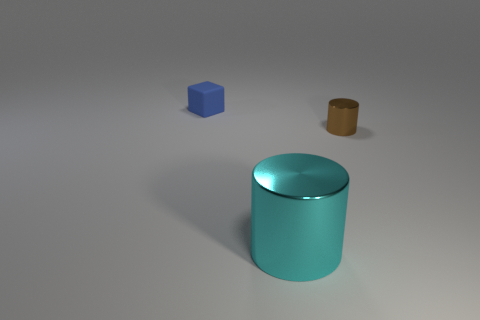Is there any other thing that is the same shape as the blue object?
Provide a succinct answer. No. What is the shape of the small rubber thing?
Give a very brief answer. Cube. What is the small object to the right of the thing that is left of the shiny cylinder that is in front of the small metal cylinder made of?
Make the answer very short. Metal. How many objects are tiny cyan shiny cubes or tiny brown cylinders?
Make the answer very short. 1. Is the material of the cylinder in front of the small brown thing the same as the tiny brown cylinder?
Offer a terse response. Yes. What number of things are things on the right side of the rubber block or large cyan blocks?
Your answer should be compact. 2. There is another cylinder that is the same material as the small cylinder; what is its color?
Provide a succinct answer. Cyan. Is there a cylinder of the same size as the matte cube?
Offer a very short reply. Yes. There is a thing that is both behind the cyan cylinder and in front of the blue matte object; what color is it?
Offer a very short reply. Brown. The brown object that is the same size as the blue object is what shape?
Make the answer very short. Cylinder. 